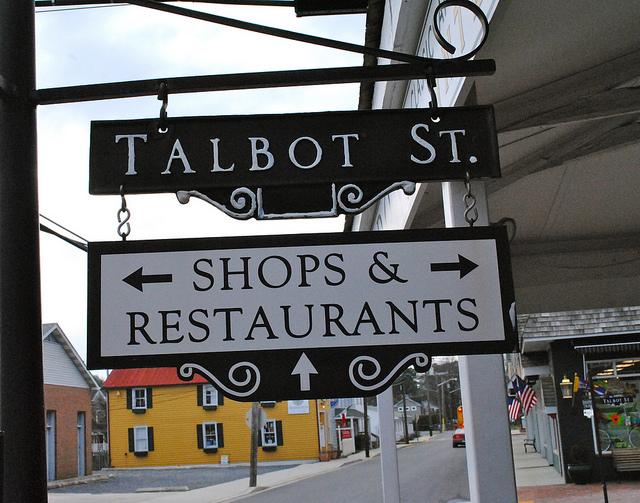What flags fly in this photo?
Be succinct. American. How many bedrooms are for rent?
Be succinct. 0. What color is the sign that reads shops & restaurants?
Give a very brief answer. White. What is the name of the street?
Quick response, please. Talbot. What color are the window shutters of the yellow building?
Give a very brief answer. Black. Is this sign red or white?
Be succinct. White. 